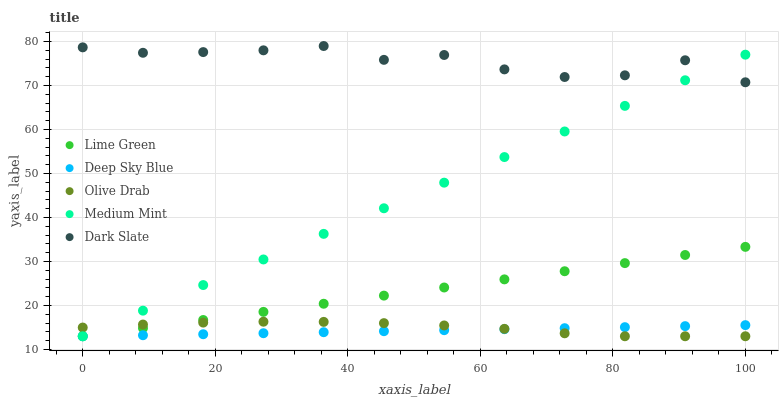Does Deep Sky Blue have the minimum area under the curve?
Answer yes or no. Yes. Does Dark Slate have the maximum area under the curve?
Answer yes or no. Yes. Does Lime Green have the minimum area under the curve?
Answer yes or no. No. Does Lime Green have the maximum area under the curve?
Answer yes or no. No. Is Lime Green the smoothest?
Answer yes or no. Yes. Is Dark Slate the roughest?
Answer yes or no. Yes. Is Dark Slate the smoothest?
Answer yes or no. No. Is Lime Green the roughest?
Answer yes or no. No. Does Medium Mint have the lowest value?
Answer yes or no. Yes. Does Dark Slate have the lowest value?
Answer yes or no. No. Does Dark Slate have the highest value?
Answer yes or no. Yes. Does Lime Green have the highest value?
Answer yes or no. No. Is Deep Sky Blue less than Dark Slate?
Answer yes or no. Yes. Is Dark Slate greater than Deep Sky Blue?
Answer yes or no. Yes. Does Lime Green intersect Medium Mint?
Answer yes or no. Yes. Is Lime Green less than Medium Mint?
Answer yes or no. No. Is Lime Green greater than Medium Mint?
Answer yes or no. No. Does Deep Sky Blue intersect Dark Slate?
Answer yes or no. No. 